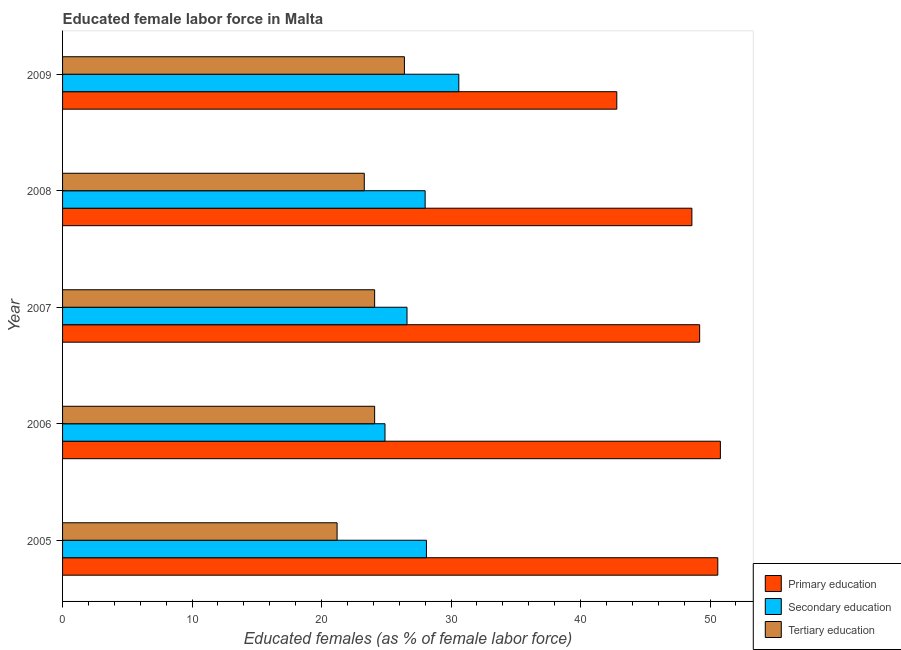How many different coloured bars are there?
Your answer should be very brief. 3. Are the number of bars on each tick of the Y-axis equal?
Your answer should be very brief. Yes. How many bars are there on the 1st tick from the top?
Offer a terse response. 3. How many bars are there on the 4th tick from the bottom?
Your answer should be compact. 3. What is the label of the 5th group of bars from the top?
Provide a short and direct response. 2005. What is the percentage of female labor force who received primary education in 2008?
Provide a short and direct response. 48.6. Across all years, what is the maximum percentage of female labor force who received tertiary education?
Provide a succinct answer. 26.4. Across all years, what is the minimum percentage of female labor force who received secondary education?
Offer a terse response. 24.9. In which year was the percentage of female labor force who received secondary education maximum?
Your answer should be very brief. 2009. In which year was the percentage of female labor force who received secondary education minimum?
Your answer should be very brief. 2006. What is the total percentage of female labor force who received primary education in the graph?
Your answer should be compact. 242. What is the difference between the percentage of female labor force who received tertiary education in 2005 and that in 2007?
Your answer should be compact. -2.9. What is the difference between the percentage of female labor force who received primary education in 2007 and the percentage of female labor force who received secondary education in 2005?
Offer a terse response. 21.1. What is the average percentage of female labor force who received secondary education per year?
Make the answer very short. 27.64. In the year 2007, what is the difference between the percentage of female labor force who received primary education and percentage of female labor force who received tertiary education?
Ensure brevity in your answer.  25.1. What is the ratio of the percentage of female labor force who received primary education in 2006 to that in 2007?
Give a very brief answer. 1.03. Is the difference between the percentage of female labor force who received primary education in 2005 and 2009 greater than the difference between the percentage of female labor force who received tertiary education in 2005 and 2009?
Your answer should be compact. Yes. What is the difference between the highest and the second highest percentage of female labor force who received primary education?
Offer a terse response. 0.2. What does the 2nd bar from the top in 2008 represents?
Your answer should be very brief. Secondary education. What does the 1st bar from the bottom in 2009 represents?
Your answer should be compact. Primary education. How many bars are there?
Give a very brief answer. 15. Are all the bars in the graph horizontal?
Offer a terse response. Yes. How many years are there in the graph?
Give a very brief answer. 5. What is the difference between two consecutive major ticks on the X-axis?
Make the answer very short. 10. Are the values on the major ticks of X-axis written in scientific E-notation?
Offer a very short reply. No. How many legend labels are there?
Offer a terse response. 3. What is the title of the graph?
Your response must be concise. Educated female labor force in Malta. Does "Natural Gas" appear as one of the legend labels in the graph?
Provide a succinct answer. No. What is the label or title of the X-axis?
Keep it short and to the point. Educated females (as % of female labor force). What is the label or title of the Y-axis?
Provide a short and direct response. Year. What is the Educated females (as % of female labor force) in Primary education in 2005?
Offer a terse response. 50.6. What is the Educated females (as % of female labor force) of Secondary education in 2005?
Make the answer very short. 28.1. What is the Educated females (as % of female labor force) in Tertiary education in 2005?
Offer a very short reply. 21.2. What is the Educated females (as % of female labor force) in Primary education in 2006?
Make the answer very short. 50.8. What is the Educated females (as % of female labor force) in Secondary education in 2006?
Make the answer very short. 24.9. What is the Educated females (as % of female labor force) of Tertiary education in 2006?
Offer a very short reply. 24.1. What is the Educated females (as % of female labor force) of Primary education in 2007?
Your response must be concise. 49.2. What is the Educated females (as % of female labor force) of Secondary education in 2007?
Offer a very short reply. 26.6. What is the Educated females (as % of female labor force) in Tertiary education in 2007?
Provide a short and direct response. 24.1. What is the Educated females (as % of female labor force) of Primary education in 2008?
Give a very brief answer. 48.6. What is the Educated females (as % of female labor force) of Tertiary education in 2008?
Provide a short and direct response. 23.3. What is the Educated females (as % of female labor force) of Primary education in 2009?
Provide a succinct answer. 42.8. What is the Educated females (as % of female labor force) in Secondary education in 2009?
Provide a succinct answer. 30.6. What is the Educated females (as % of female labor force) in Tertiary education in 2009?
Offer a very short reply. 26.4. Across all years, what is the maximum Educated females (as % of female labor force) in Primary education?
Your answer should be very brief. 50.8. Across all years, what is the maximum Educated females (as % of female labor force) in Secondary education?
Your response must be concise. 30.6. Across all years, what is the maximum Educated females (as % of female labor force) in Tertiary education?
Make the answer very short. 26.4. Across all years, what is the minimum Educated females (as % of female labor force) in Primary education?
Give a very brief answer. 42.8. Across all years, what is the minimum Educated females (as % of female labor force) of Secondary education?
Offer a very short reply. 24.9. Across all years, what is the minimum Educated females (as % of female labor force) of Tertiary education?
Make the answer very short. 21.2. What is the total Educated females (as % of female labor force) of Primary education in the graph?
Your response must be concise. 242. What is the total Educated females (as % of female labor force) of Secondary education in the graph?
Provide a succinct answer. 138.2. What is the total Educated females (as % of female labor force) of Tertiary education in the graph?
Make the answer very short. 119.1. What is the difference between the Educated females (as % of female labor force) in Primary education in 2005 and that in 2007?
Offer a very short reply. 1.4. What is the difference between the Educated females (as % of female labor force) in Secondary education in 2005 and that in 2007?
Your response must be concise. 1.5. What is the difference between the Educated females (as % of female labor force) of Tertiary education in 2005 and that in 2007?
Offer a terse response. -2.9. What is the difference between the Educated females (as % of female labor force) in Tertiary education in 2005 and that in 2008?
Provide a short and direct response. -2.1. What is the difference between the Educated females (as % of female labor force) of Secondary education in 2005 and that in 2009?
Your answer should be compact. -2.5. What is the difference between the Educated females (as % of female labor force) of Primary education in 2006 and that in 2007?
Your answer should be compact. 1.6. What is the difference between the Educated females (as % of female labor force) of Secondary education in 2006 and that in 2007?
Provide a short and direct response. -1.7. What is the difference between the Educated females (as % of female labor force) of Primary education in 2006 and that in 2009?
Provide a succinct answer. 8. What is the difference between the Educated females (as % of female labor force) of Tertiary education in 2006 and that in 2009?
Make the answer very short. -2.3. What is the difference between the Educated females (as % of female labor force) of Primary education in 2007 and that in 2009?
Your answer should be compact. 6.4. What is the difference between the Educated females (as % of female labor force) of Tertiary education in 2007 and that in 2009?
Ensure brevity in your answer.  -2.3. What is the difference between the Educated females (as % of female labor force) of Primary education in 2008 and that in 2009?
Provide a short and direct response. 5.8. What is the difference between the Educated females (as % of female labor force) in Tertiary education in 2008 and that in 2009?
Your answer should be compact. -3.1. What is the difference between the Educated females (as % of female labor force) in Primary education in 2005 and the Educated females (as % of female labor force) in Secondary education in 2006?
Ensure brevity in your answer.  25.7. What is the difference between the Educated females (as % of female labor force) of Primary education in 2005 and the Educated females (as % of female labor force) of Tertiary education in 2006?
Offer a terse response. 26.5. What is the difference between the Educated females (as % of female labor force) in Primary education in 2005 and the Educated females (as % of female labor force) in Tertiary education in 2007?
Give a very brief answer. 26.5. What is the difference between the Educated females (as % of female labor force) in Secondary education in 2005 and the Educated females (as % of female labor force) in Tertiary education in 2007?
Make the answer very short. 4. What is the difference between the Educated females (as % of female labor force) in Primary education in 2005 and the Educated females (as % of female labor force) in Secondary education in 2008?
Your response must be concise. 22.6. What is the difference between the Educated females (as % of female labor force) in Primary education in 2005 and the Educated females (as % of female labor force) in Tertiary education in 2008?
Offer a very short reply. 27.3. What is the difference between the Educated females (as % of female labor force) of Secondary education in 2005 and the Educated females (as % of female labor force) of Tertiary education in 2008?
Offer a terse response. 4.8. What is the difference between the Educated females (as % of female labor force) of Primary education in 2005 and the Educated females (as % of female labor force) of Tertiary education in 2009?
Ensure brevity in your answer.  24.2. What is the difference between the Educated females (as % of female labor force) in Primary education in 2006 and the Educated females (as % of female labor force) in Secondary education in 2007?
Give a very brief answer. 24.2. What is the difference between the Educated females (as % of female labor force) in Primary education in 2006 and the Educated females (as % of female labor force) in Tertiary education in 2007?
Keep it short and to the point. 26.7. What is the difference between the Educated females (as % of female labor force) in Secondary education in 2006 and the Educated females (as % of female labor force) in Tertiary education in 2007?
Make the answer very short. 0.8. What is the difference between the Educated females (as % of female labor force) of Primary education in 2006 and the Educated females (as % of female labor force) of Secondary education in 2008?
Offer a very short reply. 22.8. What is the difference between the Educated females (as % of female labor force) in Primary education in 2006 and the Educated females (as % of female labor force) in Tertiary education in 2008?
Your answer should be very brief. 27.5. What is the difference between the Educated females (as % of female labor force) in Secondary education in 2006 and the Educated females (as % of female labor force) in Tertiary education in 2008?
Your answer should be very brief. 1.6. What is the difference between the Educated females (as % of female labor force) in Primary education in 2006 and the Educated females (as % of female labor force) in Secondary education in 2009?
Your response must be concise. 20.2. What is the difference between the Educated females (as % of female labor force) in Primary education in 2006 and the Educated females (as % of female labor force) in Tertiary education in 2009?
Your answer should be very brief. 24.4. What is the difference between the Educated females (as % of female labor force) in Secondary education in 2006 and the Educated females (as % of female labor force) in Tertiary education in 2009?
Offer a very short reply. -1.5. What is the difference between the Educated females (as % of female labor force) in Primary education in 2007 and the Educated females (as % of female labor force) in Secondary education in 2008?
Your response must be concise. 21.2. What is the difference between the Educated females (as % of female labor force) in Primary education in 2007 and the Educated females (as % of female labor force) in Tertiary education in 2008?
Offer a very short reply. 25.9. What is the difference between the Educated females (as % of female labor force) of Primary education in 2007 and the Educated females (as % of female labor force) of Tertiary education in 2009?
Your response must be concise. 22.8. What is the difference between the Educated females (as % of female labor force) of Secondary education in 2007 and the Educated females (as % of female labor force) of Tertiary education in 2009?
Offer a terse response. 0.2. What is the difference between the Educated females (as % of female labor force) of Primary education in 2008 and the Educated females (as % of female labor force) of Secondary education in 2009?
Your answer should be very brief. 18. What is the difference between the Educated females (as % of female labor force) of Primary education in 2008 and the Educated females (as % of female labor force) of Tertiary education in 2009?
Provide a succinct answer. 22.2. What is the average Educated females (as % of female labor force) of Primary education per year?
Provide a short and direct response. 48.4. What is the average Educated females (as % of female labor force) in Secondary education per year?
Offer a very short reply. 27.64. What is the average Educated females (as % of female labor force) of Tertiary education per year?
Offer a terse response. 23.82. In the year 2005, what is the difference between the Educated females (as % of female labor force) in Primary education and Educated females (as % of female labor force) in Tertiary education?
Your answer should be very brief. 29.4. In the year 2006, what is the difference between the Educated females (as % of female labor force) of Primary education and Educated females (as % of female labor force) of Secondary education?
Your answer should be compact. 25.9. In the year 2006, what is the difference between the Educated females (as % of female labor force) in Primary education and Educated females (as % of female labor force) in Tertiary education?
Ensure brevity in your answer.  26.7. In the year 2007, what is the difference between the Educated females (as % of female labor force) in Primary education and Educated females (as % of female labor force) in Secondary education?
Your answer should be compact. 22.6. In the year 2007, what is the difference between the Educated females (as % of female labor force) of Primary education and Educated females (as % of female labor force) of Tertiary education?
Make the answer very short. 25.1. In the year 2008, what is the difference between the Educated females (as % of female labor force) in Primary education and Educated females (as % of female labor force) in Secondary education?
Provide a succinct answer. 20.6. In the year 2008, what is the difference between the Educated females (as % of female labor force) in Primary education and Educated females (as % of female labor force) in Tertiary education?
Ensure brevity in your answer.  25.3. In the year 2008, what is the difference between the Educated females (as % of female labor force) of Secondary education and Educated females (as % of female labor force) of Tertiary education?
Your answer should be compact. 4.7. In the year 2009, what is the difference between the Educated females (as % of female labor force) of Primary education and Educated females (as % of female labor force) of Secondary education?
Give a very brief answer. 12.2. In the year 2009, what is the difference between the Educated females (as % of female labor force) of Secondary education and Educated females (as % of female labor force) of Tertiary education?
Your answer should be very brief. 4.2. What is the ratio of the Educated females (as % of female labor force) in Secondary education in 2005 to that in 2006?
Provide a short and direct response. 1.13. What is the ratio of the Educated females (as % of female labor force) of Tertiary education in 2005 to that in 2006?
Your answer should be compact. 0.88. What is the ratio of the Educated females (as % of female labor force) in Primary education in 2005 to that in 2007?
Make the answer very short. 1.03. What is the ratio of the Educated females (as % of female labor force) in Secondary education in 2005 to that in 2007?
Provide a short and direct response. 1.06. What is the ratio of the Educated females (as % of female labor force) in Tertiary education in 2005 to that in 2007?
Provide a succinct answer. 0.88. What is the ratio of the Educated females (as % of female labor force) of Primary education in 2005 to that in 2008?
Keep it short and to the point. 1.04. What is the ratio of the Educated females (as % of female labor force) of Secondary education in 2005 to that in 2008?
Give a very brief answer. 1. What is the ratio of the Educated females (as % of female labor force) in Tertiary education in 2005 to that in 2008?
Ensure brevity in your answer.  0.91. What is the ratio of the Educated females (as % of female labor force) in Primary education in 2005 to that in 2009?
Your answer should be compact. 1.18. What is the ratio of the Educated females (as % of female labor force) in Secondary education in 2005 to that in 2009?
Offer a terse response. 0.92. What is the ratio of the Educated females (as % of female labor force) in Tertiary education in 2005 to that in 2009?
Offer a terse response. 0.8. What is the ratio of the Educated females (as % of female labor force) in Primary education in 2006 to that in 2007?
Your response must be concise. 1.03. What is the ratio of the Educated females (as % of female labor force) in Secondary education in 2006 to that in 2007?
Ensure brevity in your answer.  0.94. What is the ratio of the Educated females (as % of female labor force) of Tertiary education in 2006 to that in 2007?
Your response must be concise. 1. What is the ratio of the Educated females (as % of female labor force) of Primary education in 2006 to that in 2008?
Your answer should be very brief. 1.05. What is the ratio of the Educated females (as % of female labor force) in Secondary education in 2006 to that in 2008?
Your response must be concise. 0.89. What is the ratio of the Educated females (as % of female labor force) in Tertiary education in 2006 to that in 2008?
Provide a succinct answer. 1.03. What is the ratio of the Educated females (as % of female labor force) of Primary education in 2006 to that in 2009?
Your answer should be compact. 1.19. What is the ratio of the Educated females (as % of female labor force) in Secondary education in 2006 to that in 2009?
Your response must be concise. 0.81. What is the ratio of the Educated females (as % of female labor force) of Tertiary education in 2006 to that in 2009?
Your answer should be compact. 0.91. What is the ratio of the Educated females (as % of female labor force) in Primary education in 2007 to that in 2008?
Ensure brevity in your answer.  1.01. What is the ratio of the Educated females (as % of female labor force) of Tertiary education in 2007 to that in 2008?
Provide a succinct answer. 1.03. What is the ratio of the Educated females (as % of female labor force) of Primary education in 2007 to that in 2009?
Ensure brevity in your answer.  1.15. What is the ratio of the Educated females (as % of female labor force) of Secondary education in 2007 to that in 2009?
Give a very brief answer. 0.87. What is the ratio of the Educated females (as % of female labor force) of Tertiary education in 2007 to that in 2009?
Your answer should be very brief. 0.91. What is the ratio of the Educated females (as % of female labor force) in Primary education in 2008 to that in 2009?
Offer a very short reply. 1.14. What is the ratio of the Educated females (as % of female labor force) in Secondary education in 2008 to that in 2009?
Your answer should be very brief. 0.92. What is the ratio of the Educated females (as % of female labor force) in Tertiary education in 2008 to that in 2009?
Offer a terse response. 0.88. What is the difference between the highest and the second highest Educated females (as % of female labor force) of Secondary education?
Provide a succinct answer. 2.5. What is the difference between the highest and the lowest Educated females (as % of female labor force) of Secondary education?
Offer a terse response. 5.7. What is the difference between the highest and the lowest Educated females (as % of female labor force) of Tertiary education?
Ensure brevity in your answer.  5.2. 